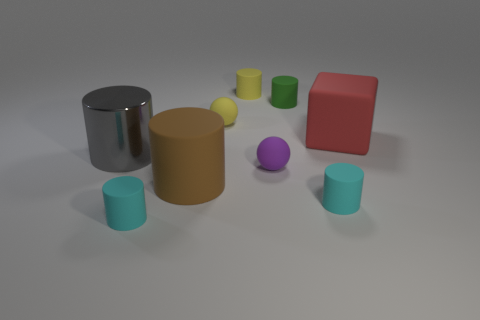Subtract all blue spheres. Subtract all yellow cylinders. How many spheres are left? 2 Subtract all green cylinders. How many purple blocks are left? 0 Add 5 blues. How many objects exist? 0 Subtract all tiny yellow things. Subtract all gray rubber cubes. How many objects are left? 7 Add 2 large gray metallic things. How many large gray metallic things are left? 3 Add 2 red rubber things. How many red rubber things exist? 3 Add 1 green cylinders. How many objects exist? 10 Subtract all yellow spheres. How many spheres are left? 1 Subtract all brown rubber cylinders. How many cylinders are left? 5 Subtract 0 purple cylinders. How many objects are left? 9 